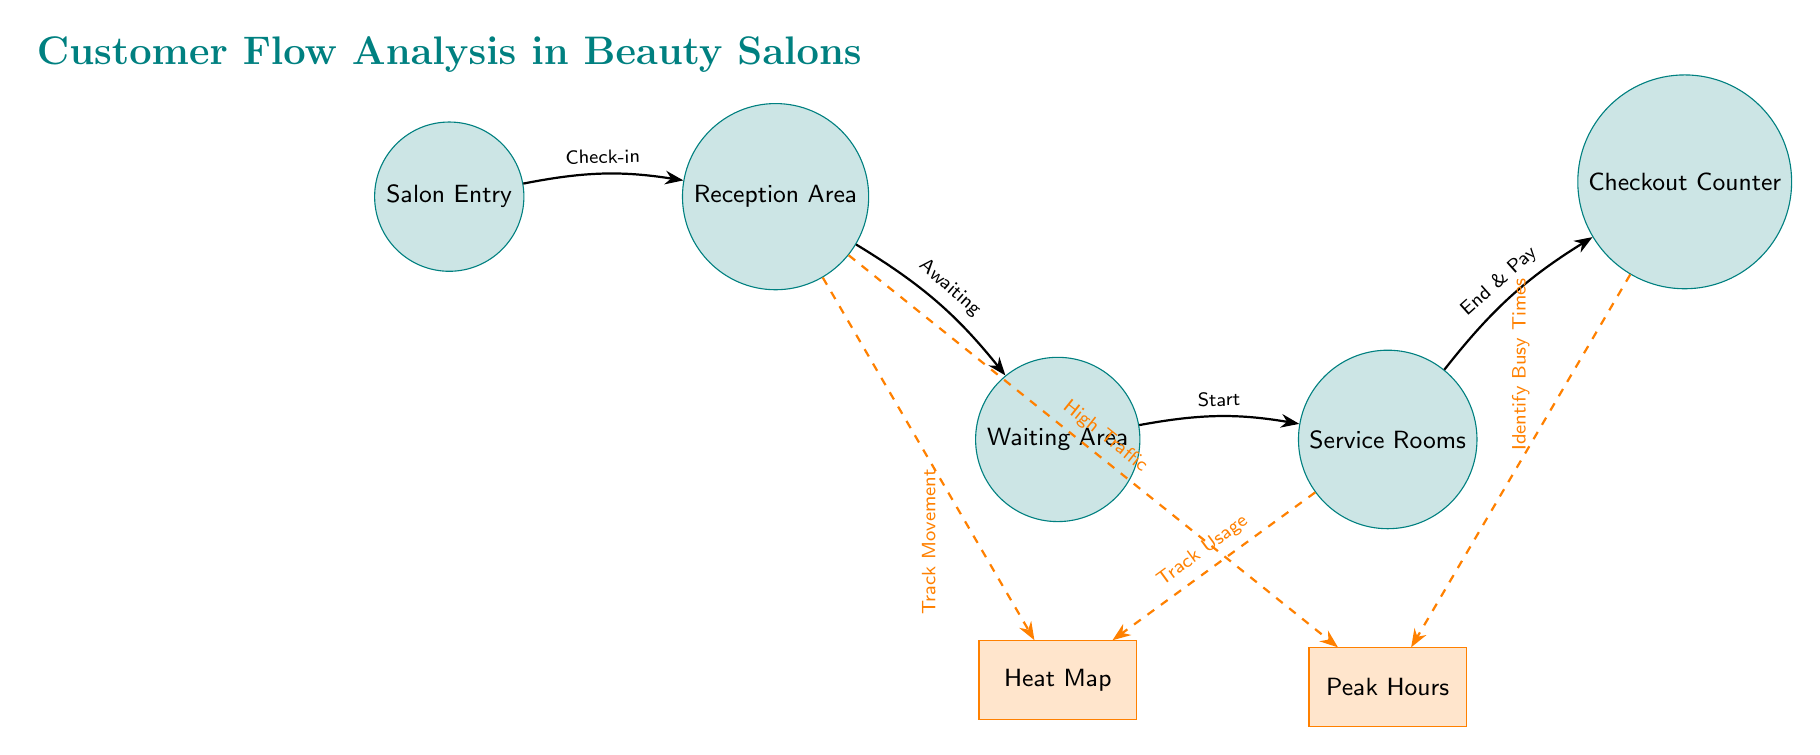What is at the top of the diagram? The top of the diagram features the title "Customer Flow Analysis in Beauty Salons," which provides context for the entire diagram.
Answer: Customer Flow Analysis in Beauty Salons How many places are shown in the diagram? The diagram includes five places: Salon Entry, Reception Area, Waiting Area, Service Rooms, and Checkout Counter. Therefore, the total count of places is five.
Answer: 5 What transition occurs between the reception area and the waiting area? The transition from the reception area to the waiting area is labeled "Awaiting," indicating the process that takes place as customers move from reception to waiting.
Answer: Awaiting Which node connects to the heat map from the reception area? The transition from the reception area to the heat map is labeled "Track Movement," indicating that the reception area plays a role in tracking customer movement for analysis.
Answer: Track Movement What does the checkout counter identify? The checkout counter is linked to the "Identify Busy Times" analysis, showing that it plays a role in determining peak hours by tracking when customers check out.
Answer: Identify Busy Times What type of analysis is associated with the service rooms? The service rooms are connected to the heat map through the transition labeled "Track Usage," indicating that this area is analyzed for usage frequency.
Answer: Track Usage Which two areas are primarily involved in determining peak hours? The checkout counter and the reception area both have connections to the peak hours analysis, indicating they are responsible for analyzing busy times.
Answer: Checkout Counter and Reception Area What does the waiting area primarily track? The waiting area primarily tracks customer movement and flow as indicated by its connection to the heat map for movement analysis.
Answer: Track Movement What is the relationship between the service rooms and the checkout counter? Customers transition from the service rooms to the checkout counter with the process labeled "End & Pay," defining the flow of service to payment.
Answer: End & Pay 